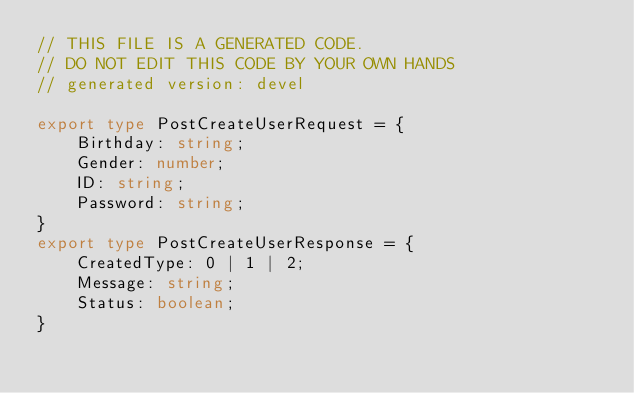Convert code to text. <code><loc_0><loc_0><loc_500><loc_500><_TypeScript_>// THIS FILE IS A GENERATED CODE.
// DO NOT EDIT THIS CODE BY YOUR OWN HANDS
// generated version: devel

export type PostCreateUserRequest = {
	Birthday: string;
	Gender: number;
	ID: string;
	Password: string;
}
export type PostCreateUserResponse = {
	CreatedType: 0 | 1 | 2;
	Message: string;
	Status: boolean;
}
</code> 